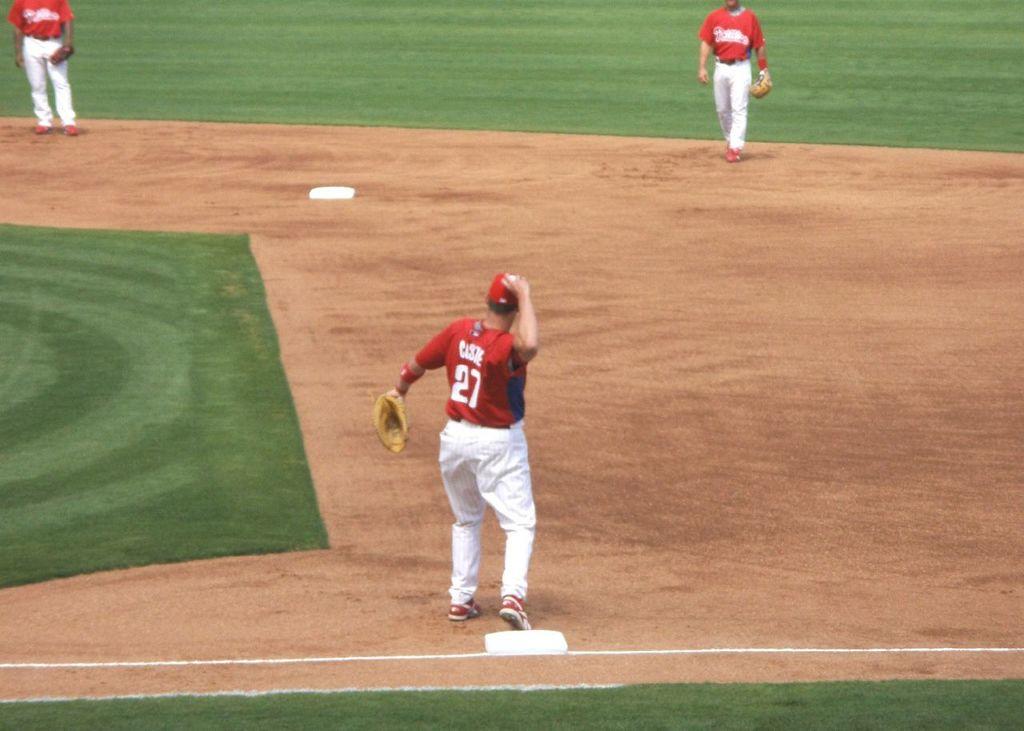What is the player's number?
Give a very brief answer. 27. What is the name written above the number 27?
Your answer should be very brief. Unanswerable. 